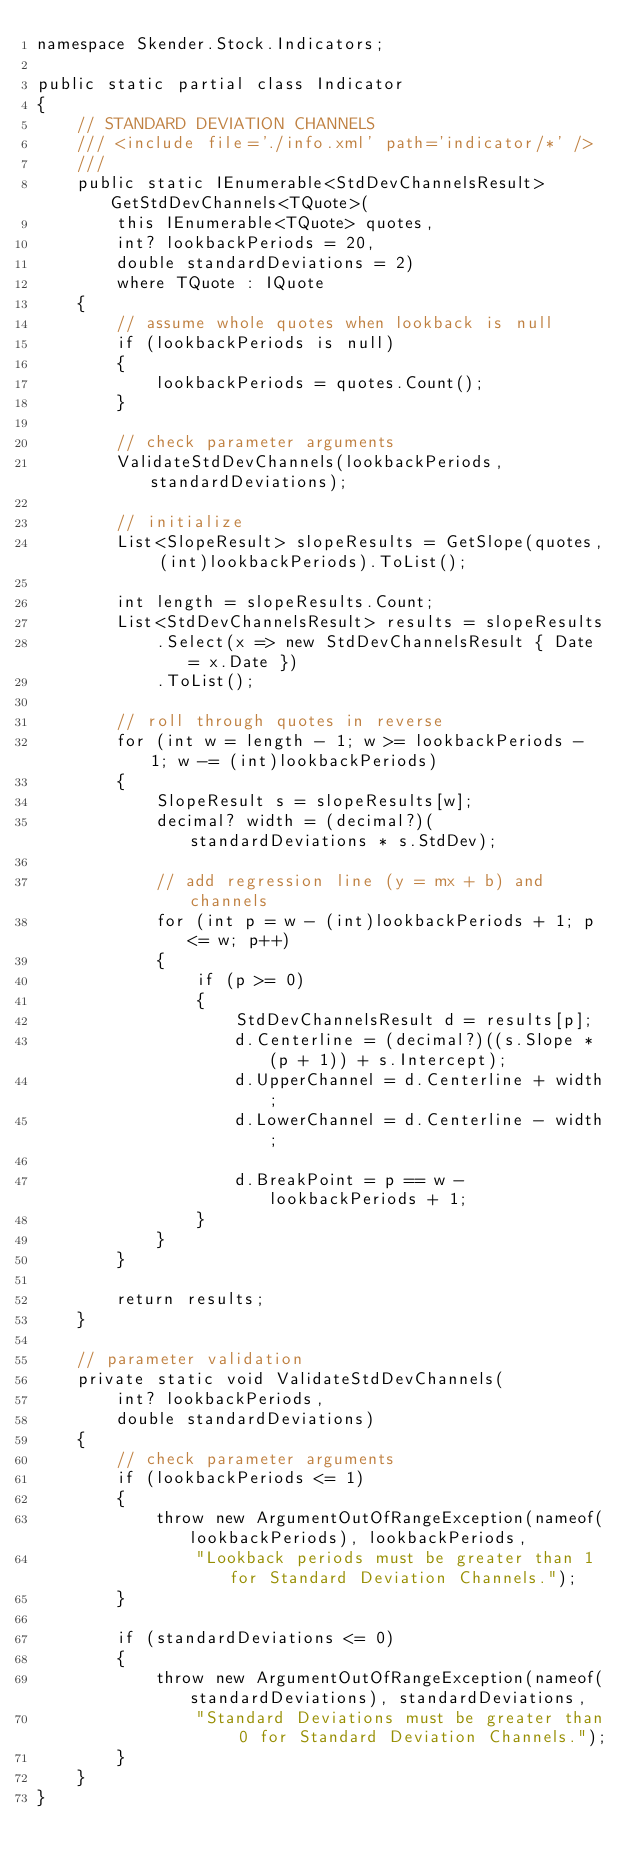<code> <loc_0><loc_0><loc_500><loc_500><_C#_>namespace Skender.Stock.Indicators;

public static partial class Indicator
{
    // STANDARD DEVIATION CHANNELS
    /// <include file='./info.xml' path='indicator/*' />
    ///
    public static IEnumerable<StdDevChannelsResult> GetStdDevChannels<TQuote>(
        this IEnumerable<TQuote> quotes,
        int? lookbackPeriods = 20,
        double standardDeviations = 2)
        where TQuote : IQuote
    {
        // assume whole quotes when lookback is null
        if (lookbackPeriods is null)
        {
            lookbackPeriods = quotes.Count();
        }

        // check parameter arguments
        ValidateStdDevChannels(lookbackPeriods, standardDeviations);

        // initialize
        List<SlopeResult> slopeResults = GetSlope(quotes, (int)lookbackPeriods).ToList();

        int length = slopeResults.Count;
        List<StdDevChannelsResult> results = slopeResults
            .Select(x => new StdDevChannelsResult { Date = x.Date })
            .ToList();

        // roll through quotes in reverse
        for (int w = length - 1; w >= lookbackPeriods - 1; w -= (int)lookbackPeriods)
        {
            SlopeResult s = slopeResults[w];
            decimal? width = (decimal?)(standardDeviations * s.StdDev);

            // add regression line (y = mx + b) and channels
            for (int p = w - (int)lookbackPeriods + 1; p <= w; p++)
            {
                if (p >= 0)
                {
                    StdDevChannelsResult d = results[p];
                    d.Centerline = (decimal?)((s.Slope * (p + 1)) + s.Intercept);
                    d.UpperChannel = d.Centerline + width;
                    d.LowerChannel = d.Centerline - width;

                    d.BreakPoint = p == w - lookbackPeriods + 1;
                }
            }
        }

        return results;
    }

    // parameter validation
    private static void ValidateStdDevChannels(
        int? lookbackPeriods,
        double standardDeviations)
    {
        // check parameter arguments
        if (lookbackPeriods <= 1)
        {
            throw new ArgumentOutOfRangeException(nameof(lookbackPeriods), lookbackPeriods,
                "Lookback periods must be greater than 1 for Standard Deviation Channels.");
        }

        if (standardDeviations <= 0)
        {
            throw new ArgumentOutOfRangeException(nameof(standardDeviations), standardDeviations,
                "Standard Deviations must be greater than 0 for Standard Deviation Channels.");
        }
    }
}
</code> 